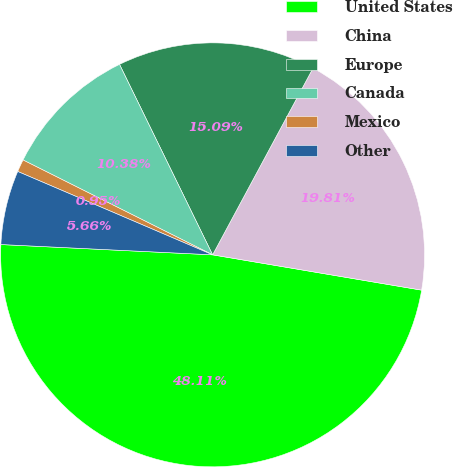<chart> <loc_0><loc_0><loc_500><loc_500><pie_chart><fcel>United States<fcel>China<fcel>Europe<fcel>Canada<fcel>Mexico<fcel>Other<nl><fcel>48.11%<fcel>19.81%<fcel>15.09%<fcel>10.38%<fcel>0.95%<fcel>5.66%<nl></chart> 